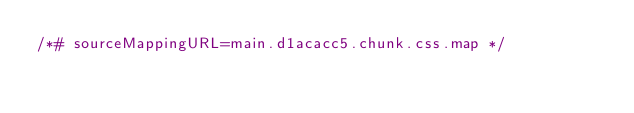<code> <loc_0><loc_0><loc_500><loc_500><_CSS_>/*# sourceMappingURL=main.d1acacc5.chunk.css.map */</code> 